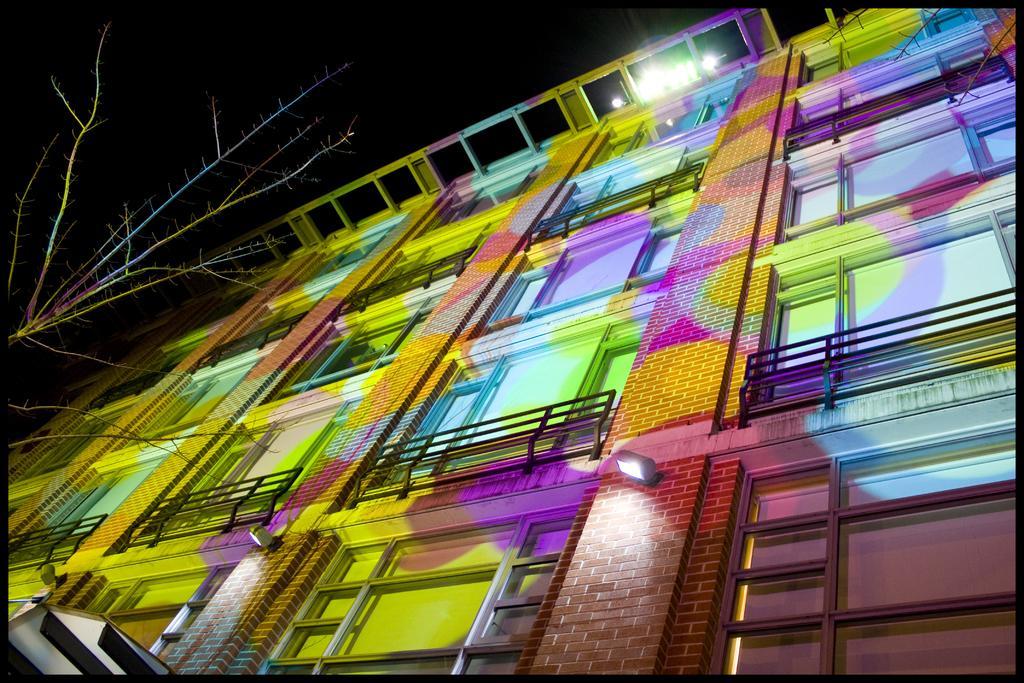How would you summarize this image in a sentence or two? In this image there is a building having different colours on it. Left side there is a tree. Top of building there are few lights. Few lights are attached to the wall of the building. 